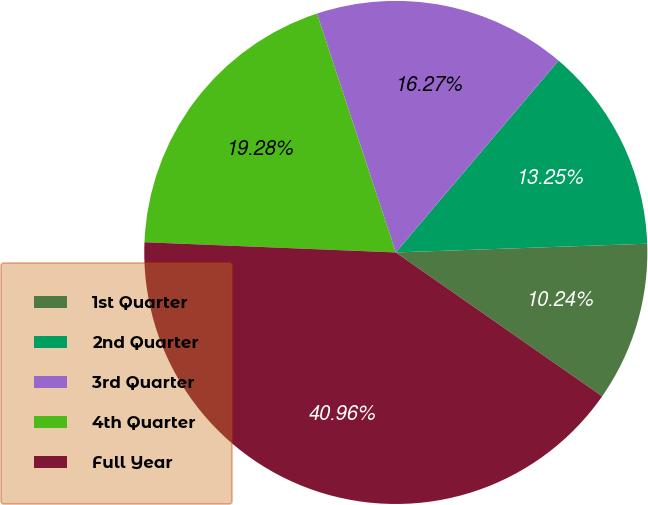Convert chart to OTSL. <chart><loc_0><loc_0><loc_500><loc_500><pie_chart><fcel>1st Quarter<fcel>2nd Quarter<fcel>3rd Quarter<fcel>4th Quarter<fcel>Full Year<nl><fcel>10.24%<fcel>13.25%<fcel>16.27%<fcel>19.28%<fcel>40.96%<nl></chart> 